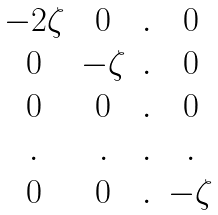Convert formula to latex. <formula><loc_0><loc_0><loc_500><loc_500>\begin{matrix} - 2 \zeta & 0 & . & 0 \\ 0 & - \zeta & . & 0 \\ 0 & 0 & . & 0 \\ . & . & . & . \\ 0 & 0 & . & - \zeta \end{matrix}</formula> 